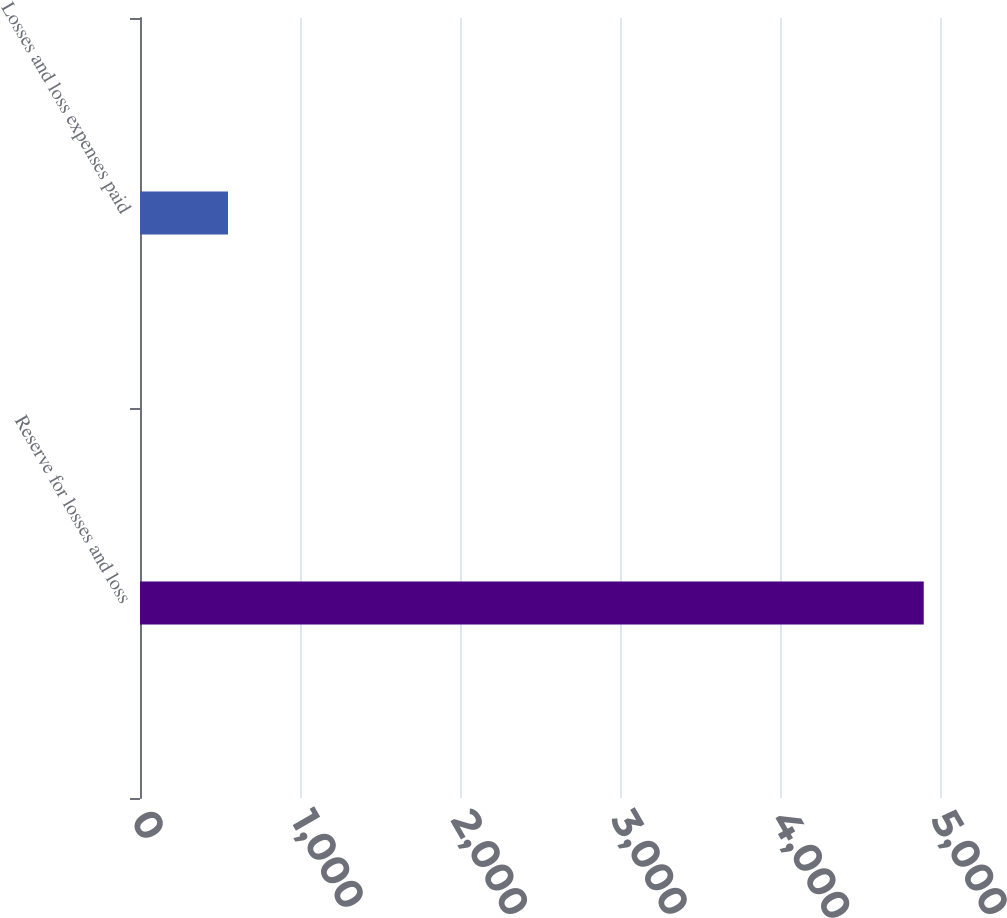Convert chart. <chart><loc_0><loc_0><loc_500><loc_500><bar_chart><fcel>Reserve for losses and loss<fcel>Losses and loss expenses paid<nl><fcel>4898.3<fcel>550<nl></chart> 